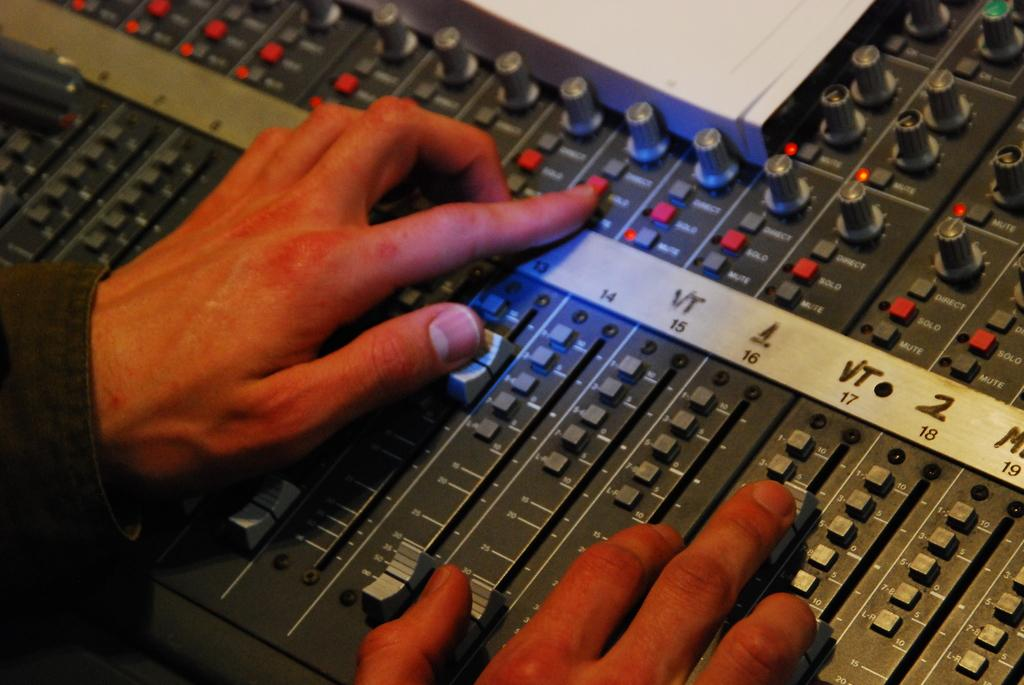Provide a one-sentence caption for the provided image. two hands working controls on a board that has a strip with numbers 14, 15, 16, 17, 18, 19 on it. 